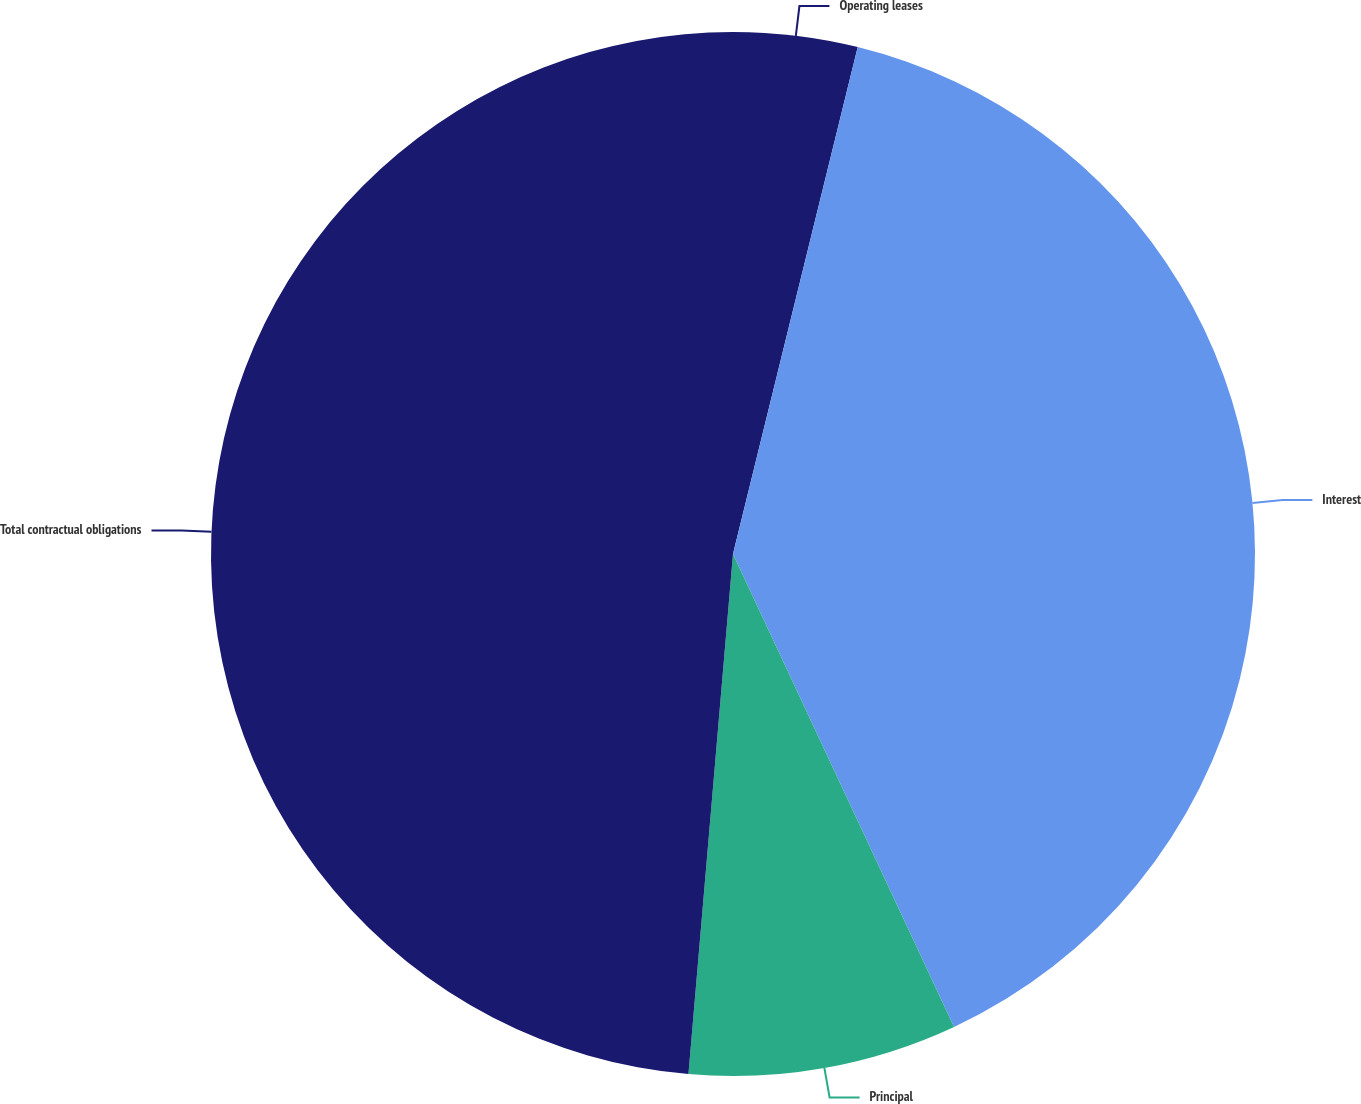<chart> <loc_0><loc_0><loc_500><loc_500><pie_chart><fcel>Operating leases<fcel>Interest<fcel>Principal<fcel>Total contractual obligations<nl><fcel>3.84%<fcel>39.2%<fcel>8.32%<fcel>48.64%<nl></chart> 